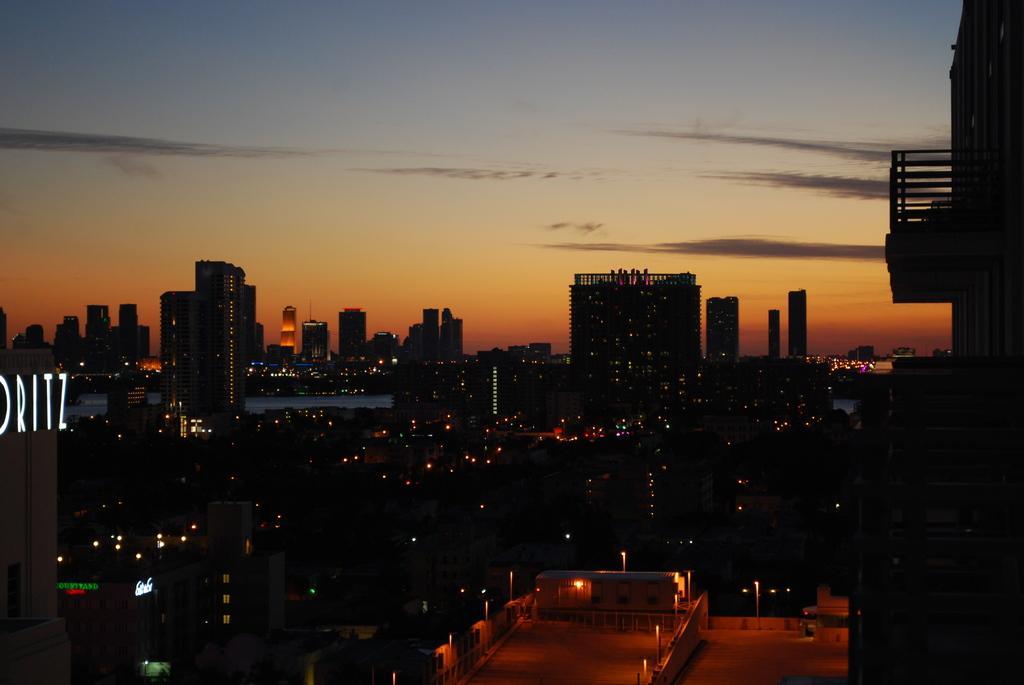Could you give a brief overview of what you see in this image? In this image we can see buildings with lights. At the top of the image, there is the sky. 